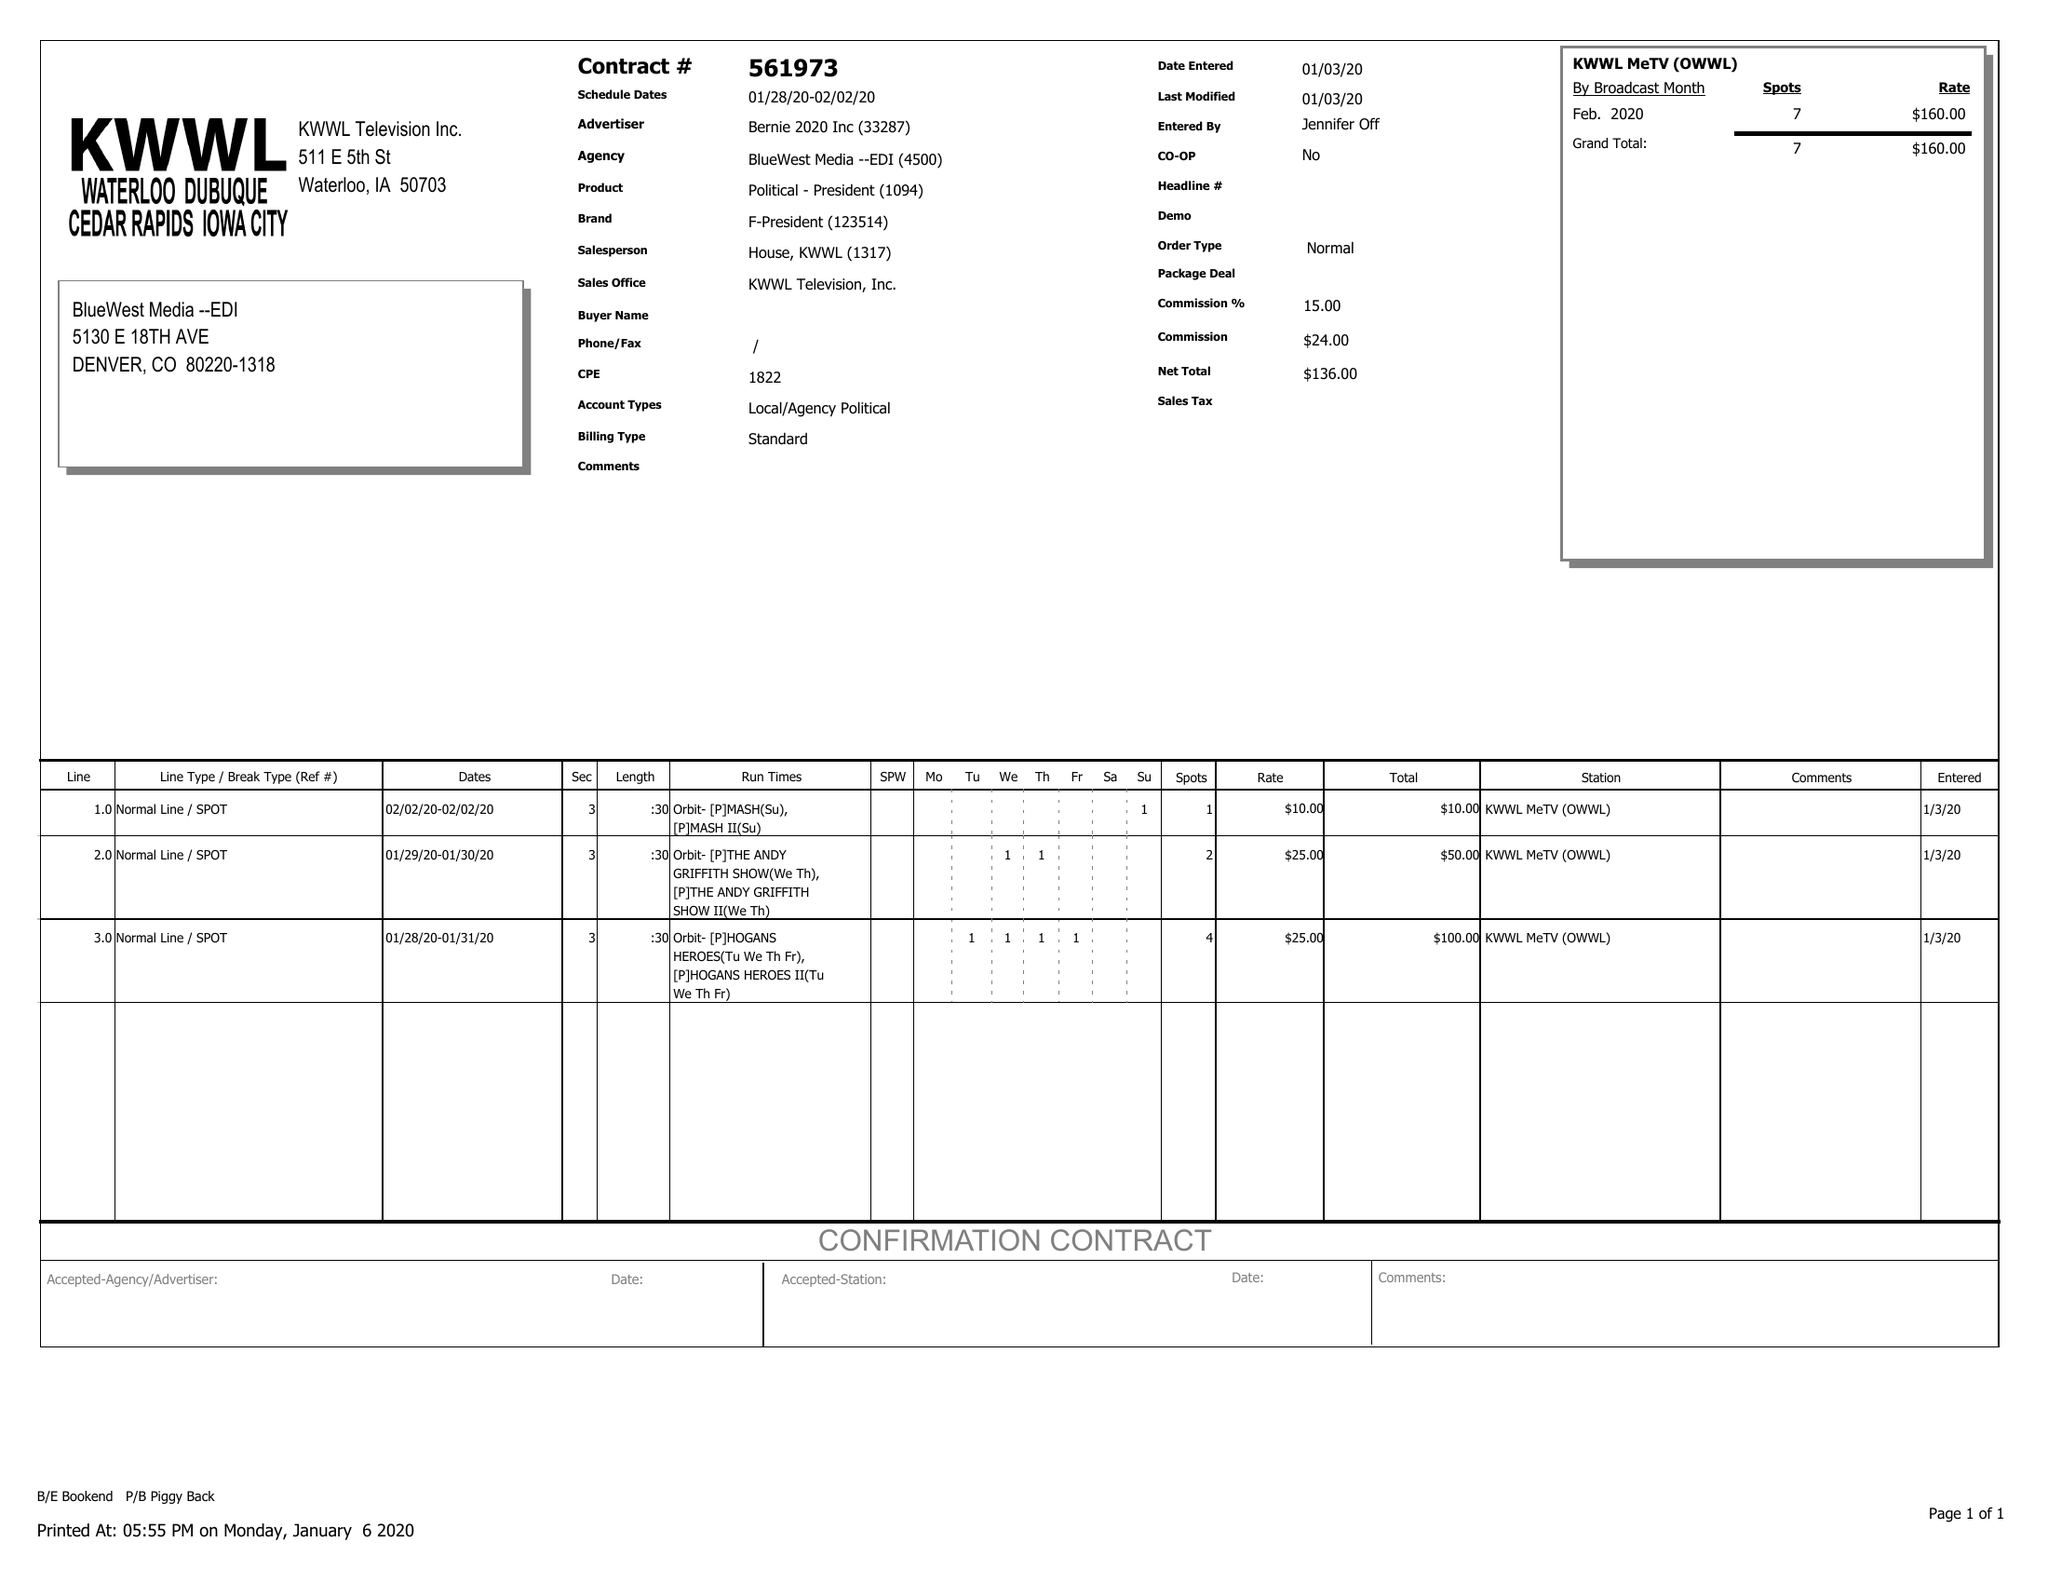What is the value for the flight_to?
Answer the question using a single word or phrase. 02/02/20 